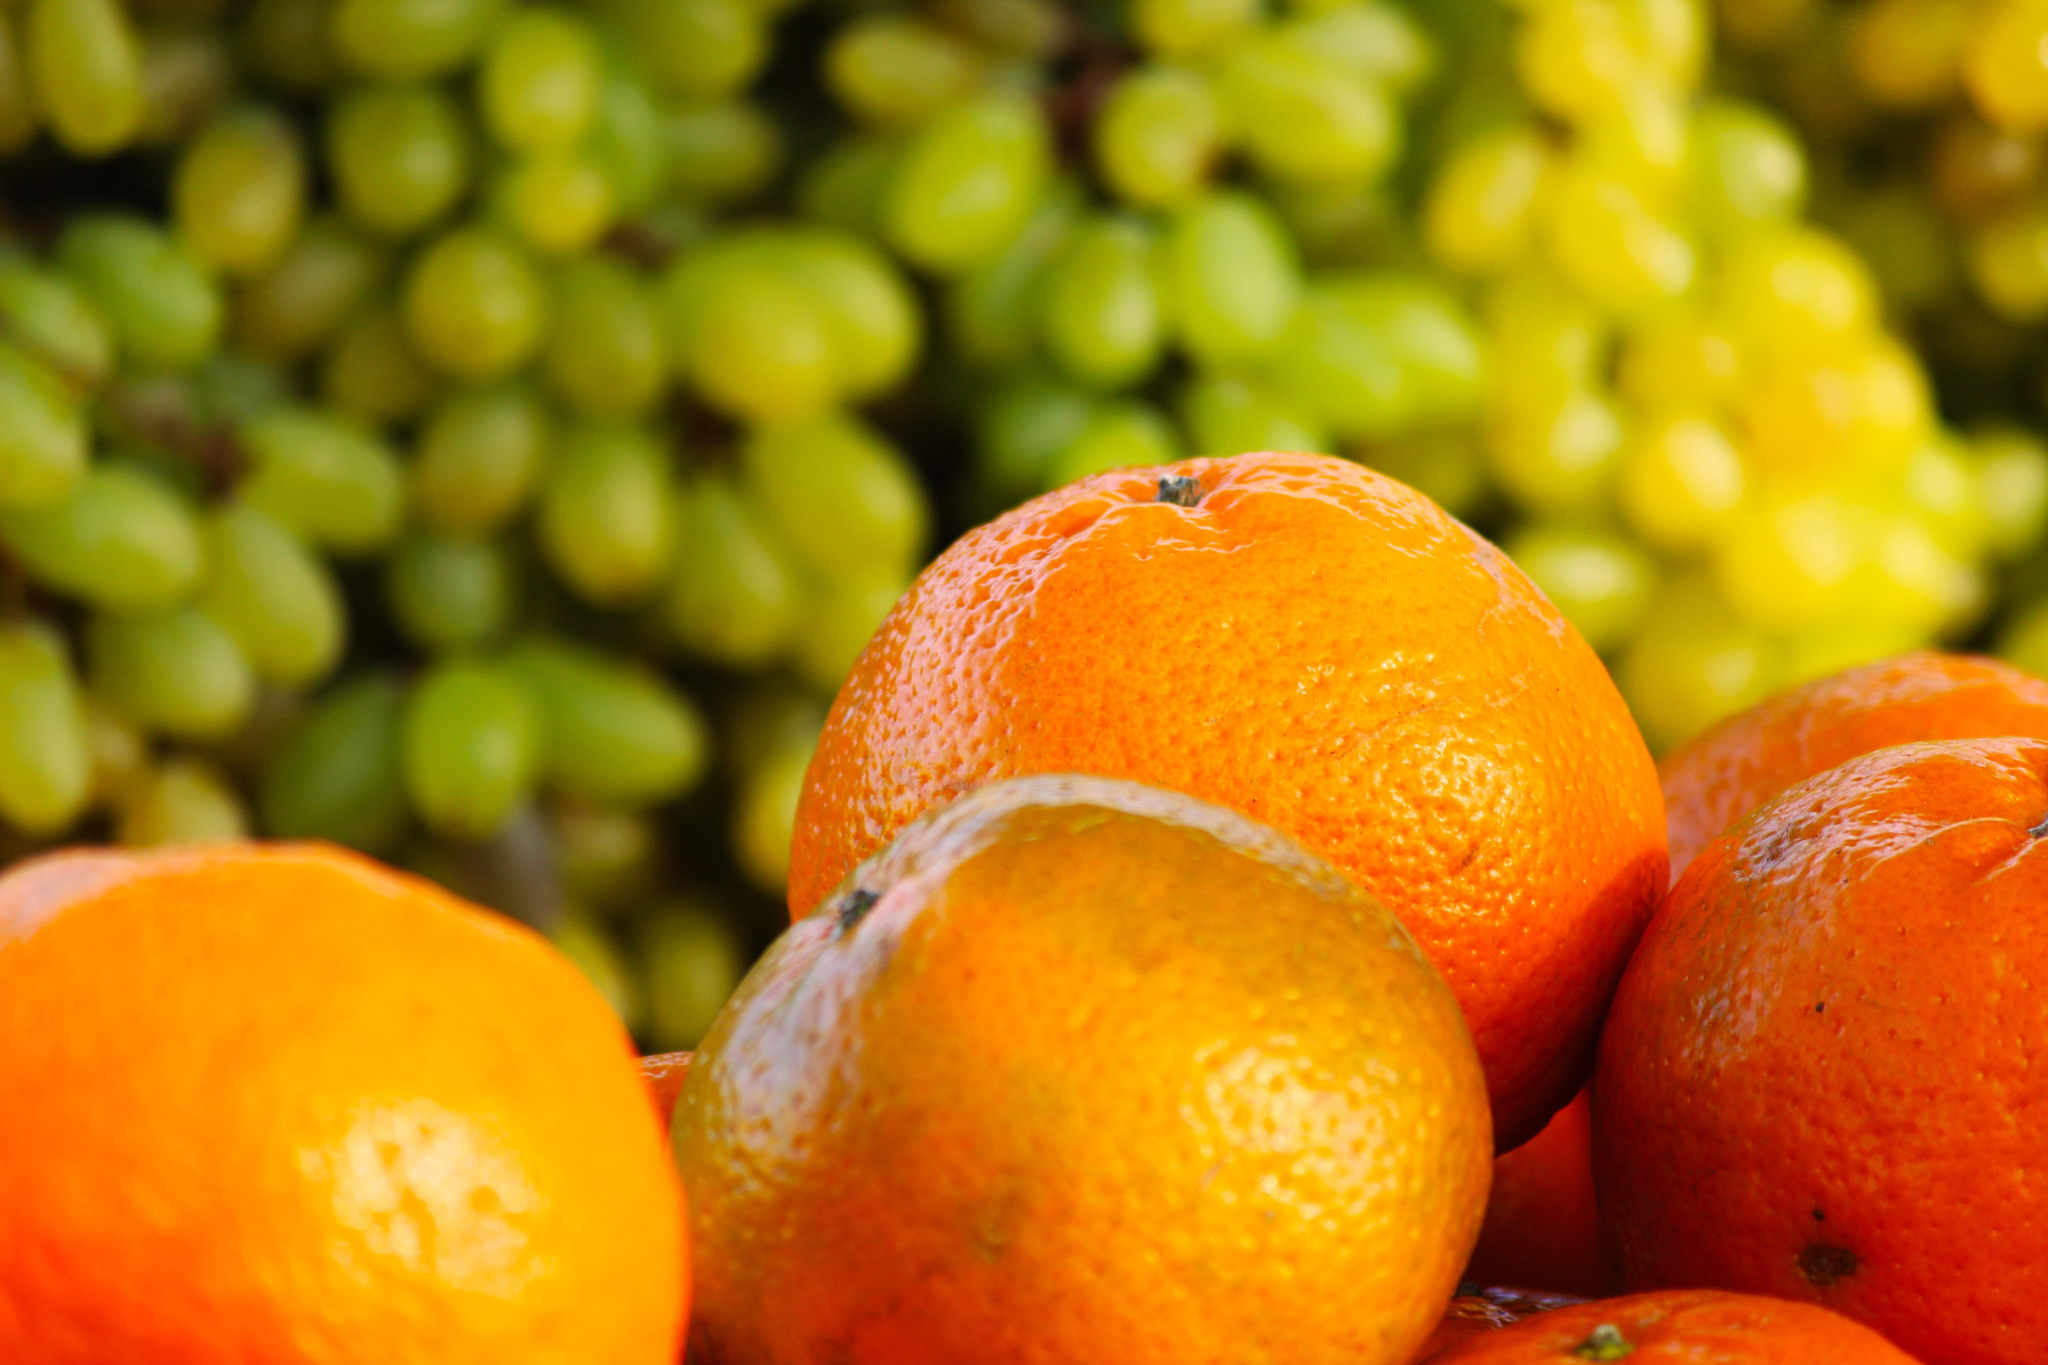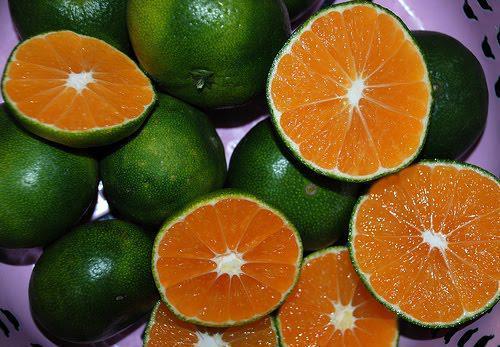The first image is the image on the left, the second image is the image on the right. For the images displayed, is the sentence "A fruit with a green skin is revealing an orange inside in one of the images." factually correct? Answer yes or no. Yes. The first image is the image on the left, the second image is the image on the right. Given the left and right images, does the statement "In one of the images there are at least three oranges still attached to the tree." hold true? Answer yes or no. No. 